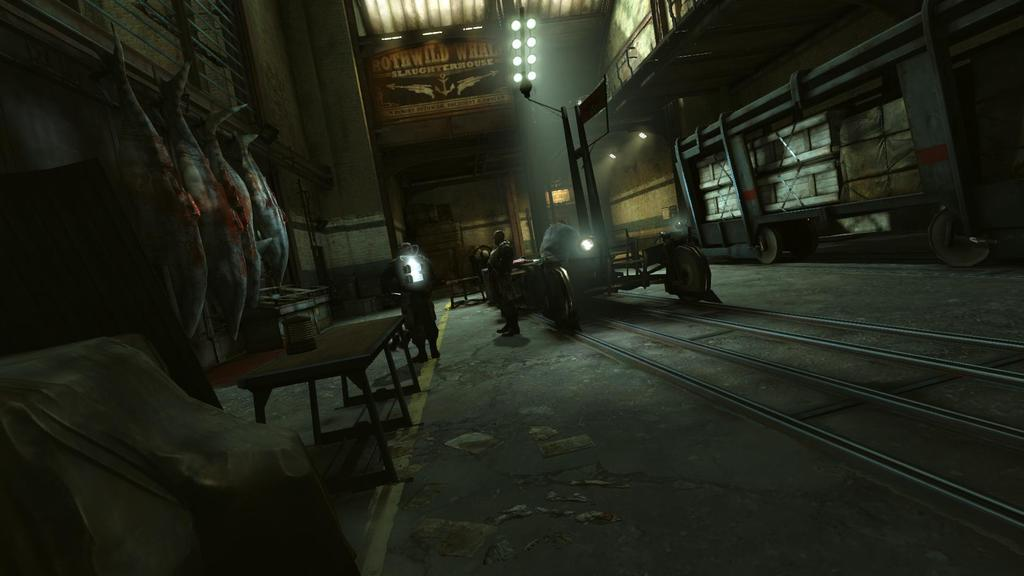What type of location is depicted in the image? The image shows an inside view of a building. What can be seen on the ground in the image? There are people on the ground in the image. What piece of furniture is present in the image? There is a table in the image. What type of food is visible in the image? Meat is visible in the image. What architectural feature is present in the image? There is a wall in the image. What source of illumination is present in the image? Lights are present in the image. What type of cork can be seen on the table in the image? There is no cork present on the table in the image. What type of conversation is happening between the people in the image? The image does not show or imply any conversation between the people; it only shows their presence on the ground. 